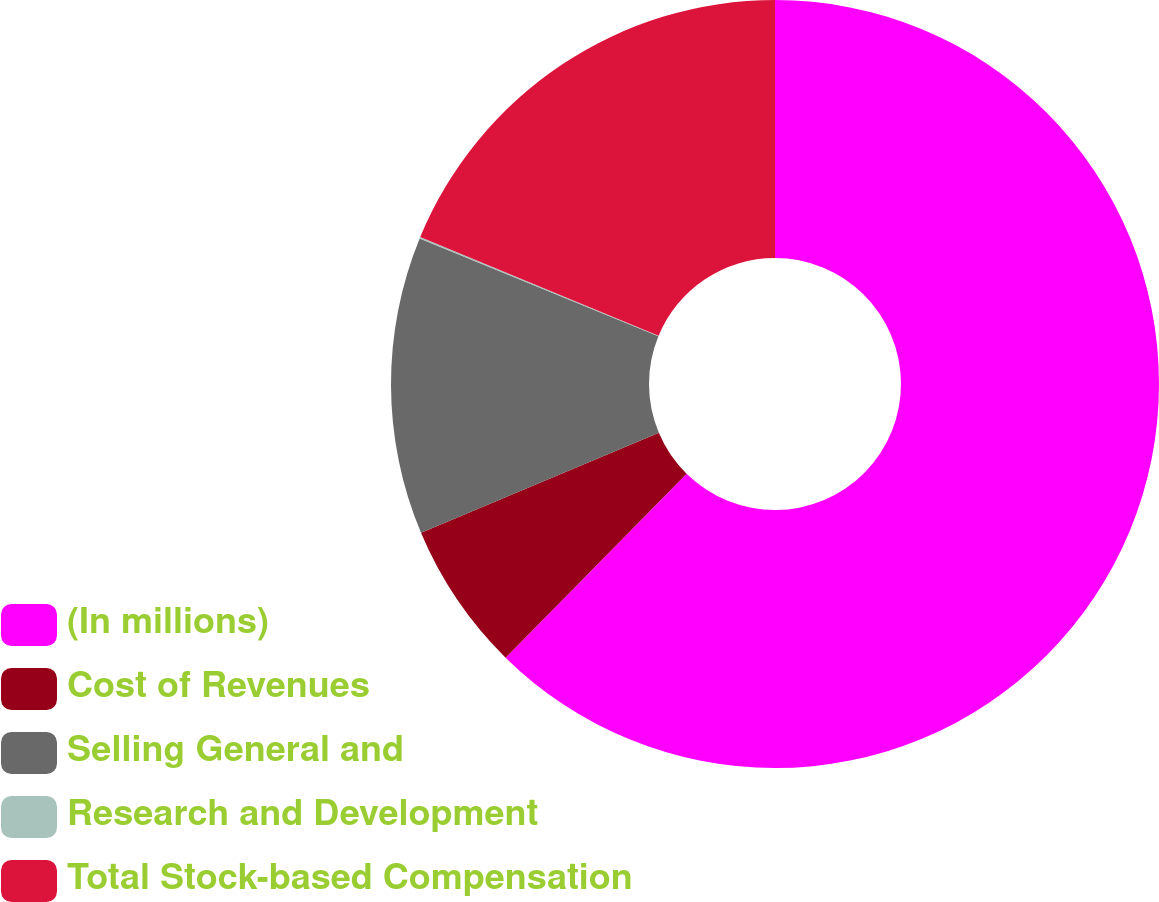Convert chart. <chart><loc_0><loc_0><loc_500><loc_500><pie_chart><fcel>(In millions)<fcel>Cost of Revenues<fcel>Selling General and<fcel>Research and Development<fcel>Total Stock-based Compensation<nl><fcel>62.37%<fcel>6.29%<fcel>12.52%<fcel>0.06%<fcel>18.75%<nl></chart> 